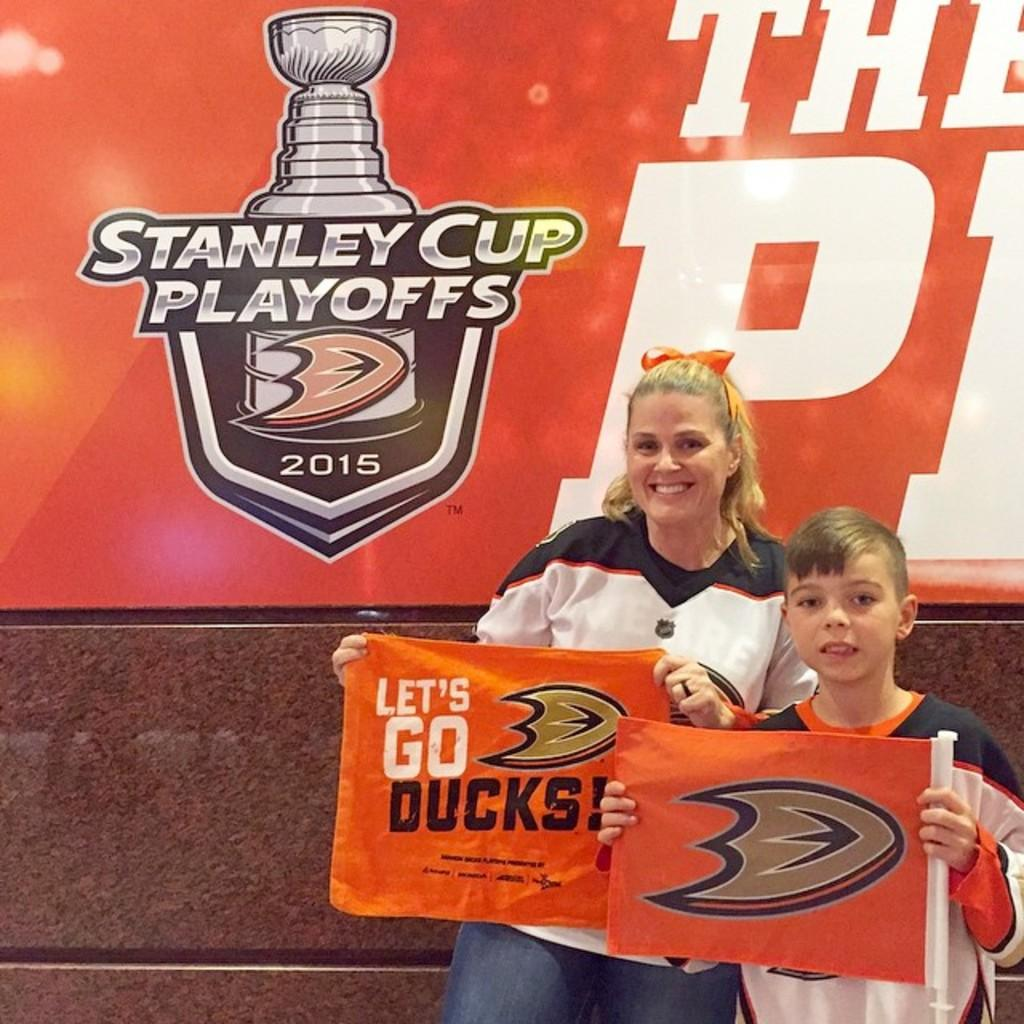What are the two people in the image doing? The two people in the image are holding a banner. What else can be seen in the image besides the people holding the banner? There is a poster visible in the image. Can you describe the poster in more detail? The poster has a logo and some letters on it. What type of hair can be seen on the minister in the image? There is no minister or hair present in the image. How does the breath of the people holding the banner appear in the image? There is no indication of breath in the image; it only shows the people holding the banner and the poster. 